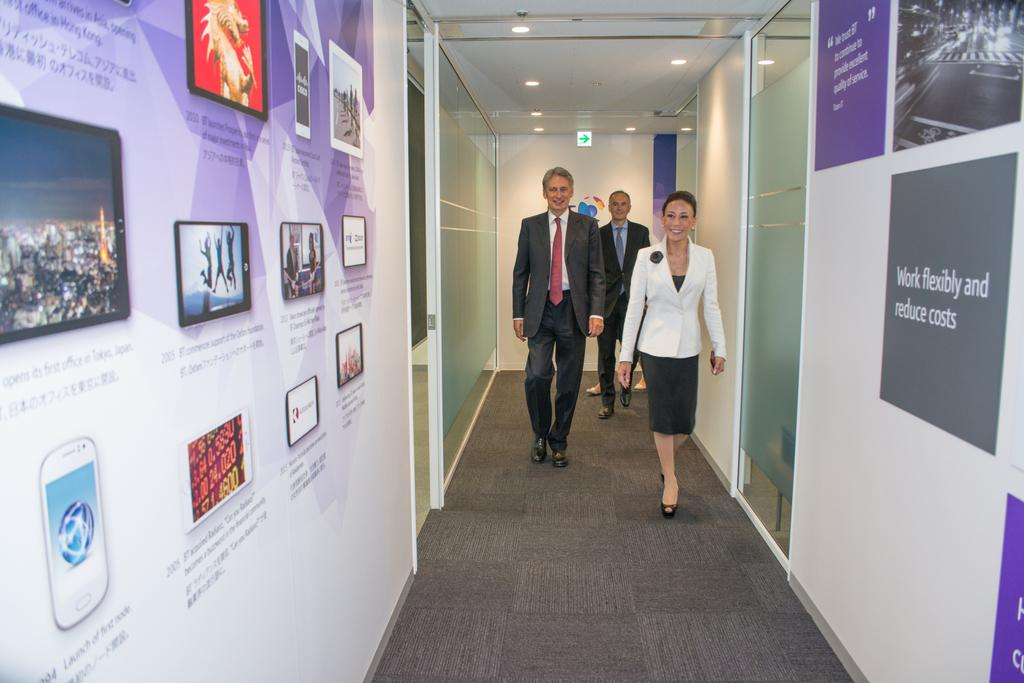<image>
Relay a brief, clear account of the picture shown. A number of posters adorn a hallway with encourages slogans like Work Flexibility and Fixed Costs. 